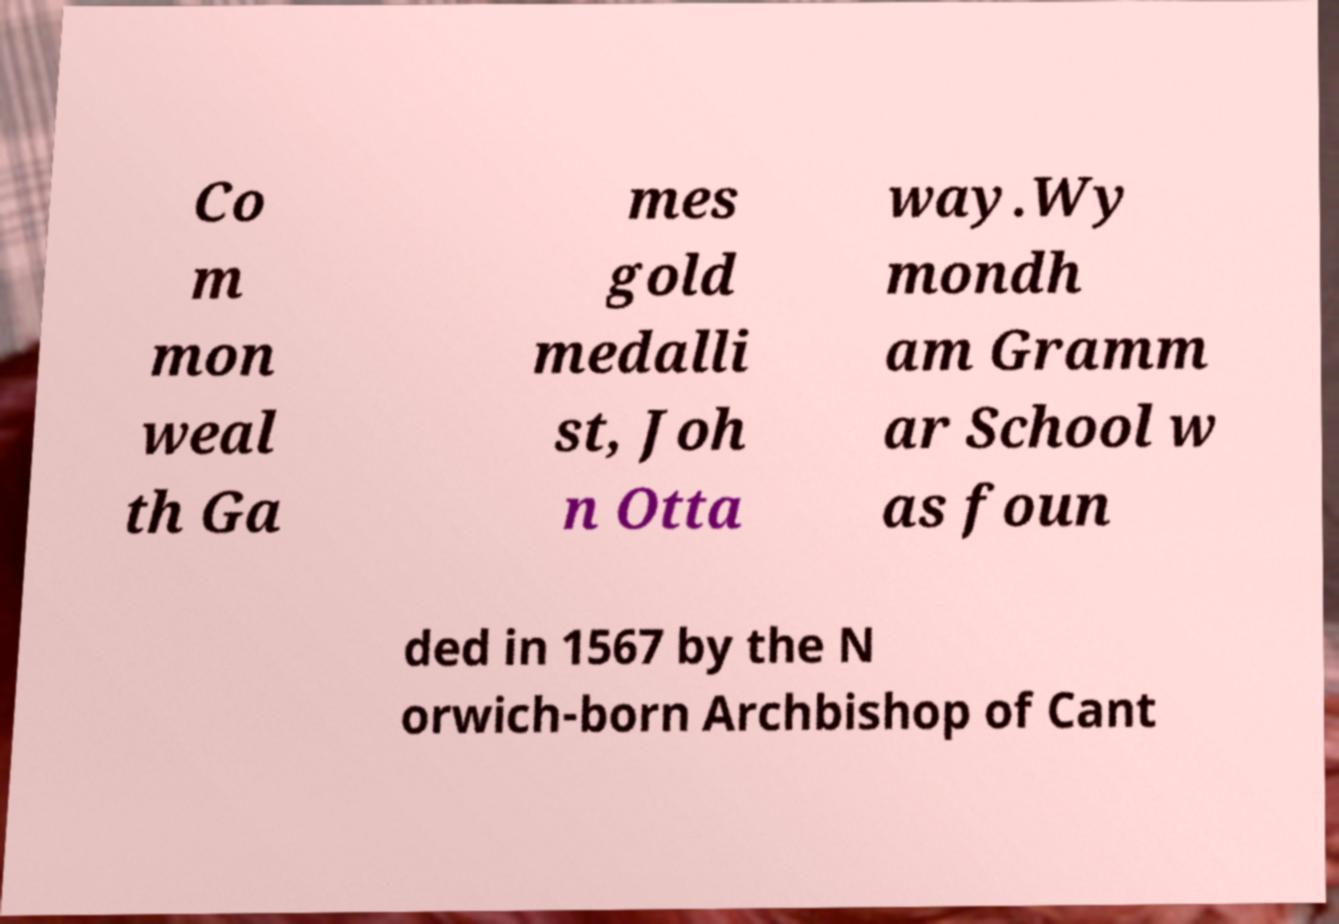There's text embedded in this image that I need extracted. Can you transcribe it verbatim? Co m mon weal th Ga mes gold medalli st, Joh n Otta way.Wy mondh am Gramm ar School w as foun ded in 1567 by the N orwich-born Archbishop of Cant 